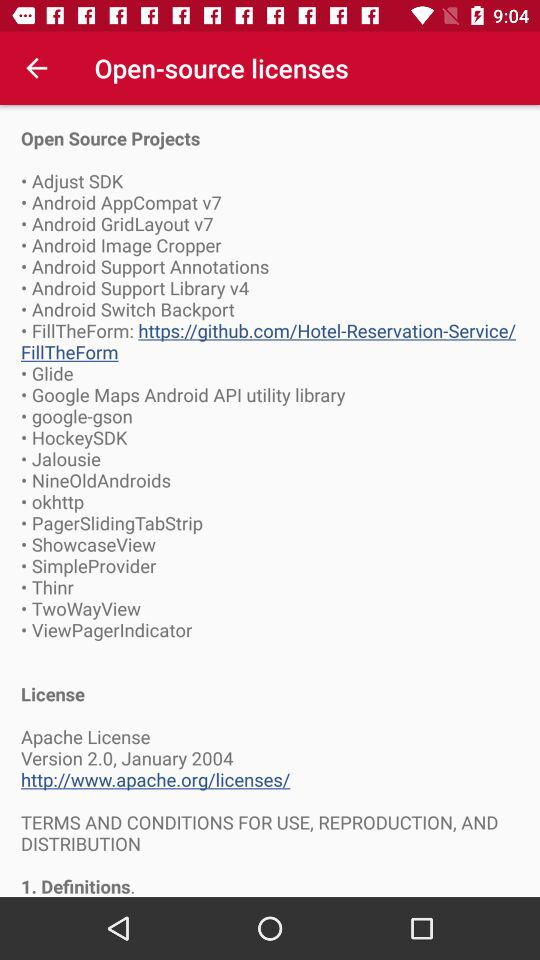What year is Version 2.0 released? Version 2.0 is released in 2004. 